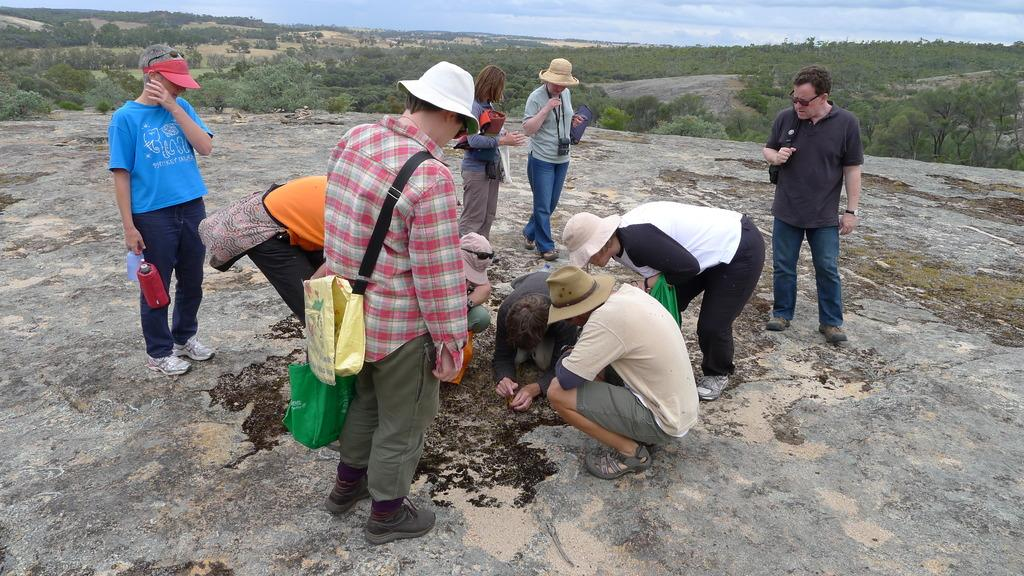What is happening in the foreground of the image? There are persons in the foreground of the image, some of whom are squatting and others standing on the cliff. Can you describe the position of the persons in the image? Some of the persons are squatting, while others are standing on the cliff. What can be seen in the background of the image? There are trees and the sky visible in the background of the image. What is the condition of the sky in the image? The sky is visible in the background of the image, and there are clouds present. What type of spoon is being used by the cows in the image? There are no cows present in the image, and therefore no spoons can be associated with them. 